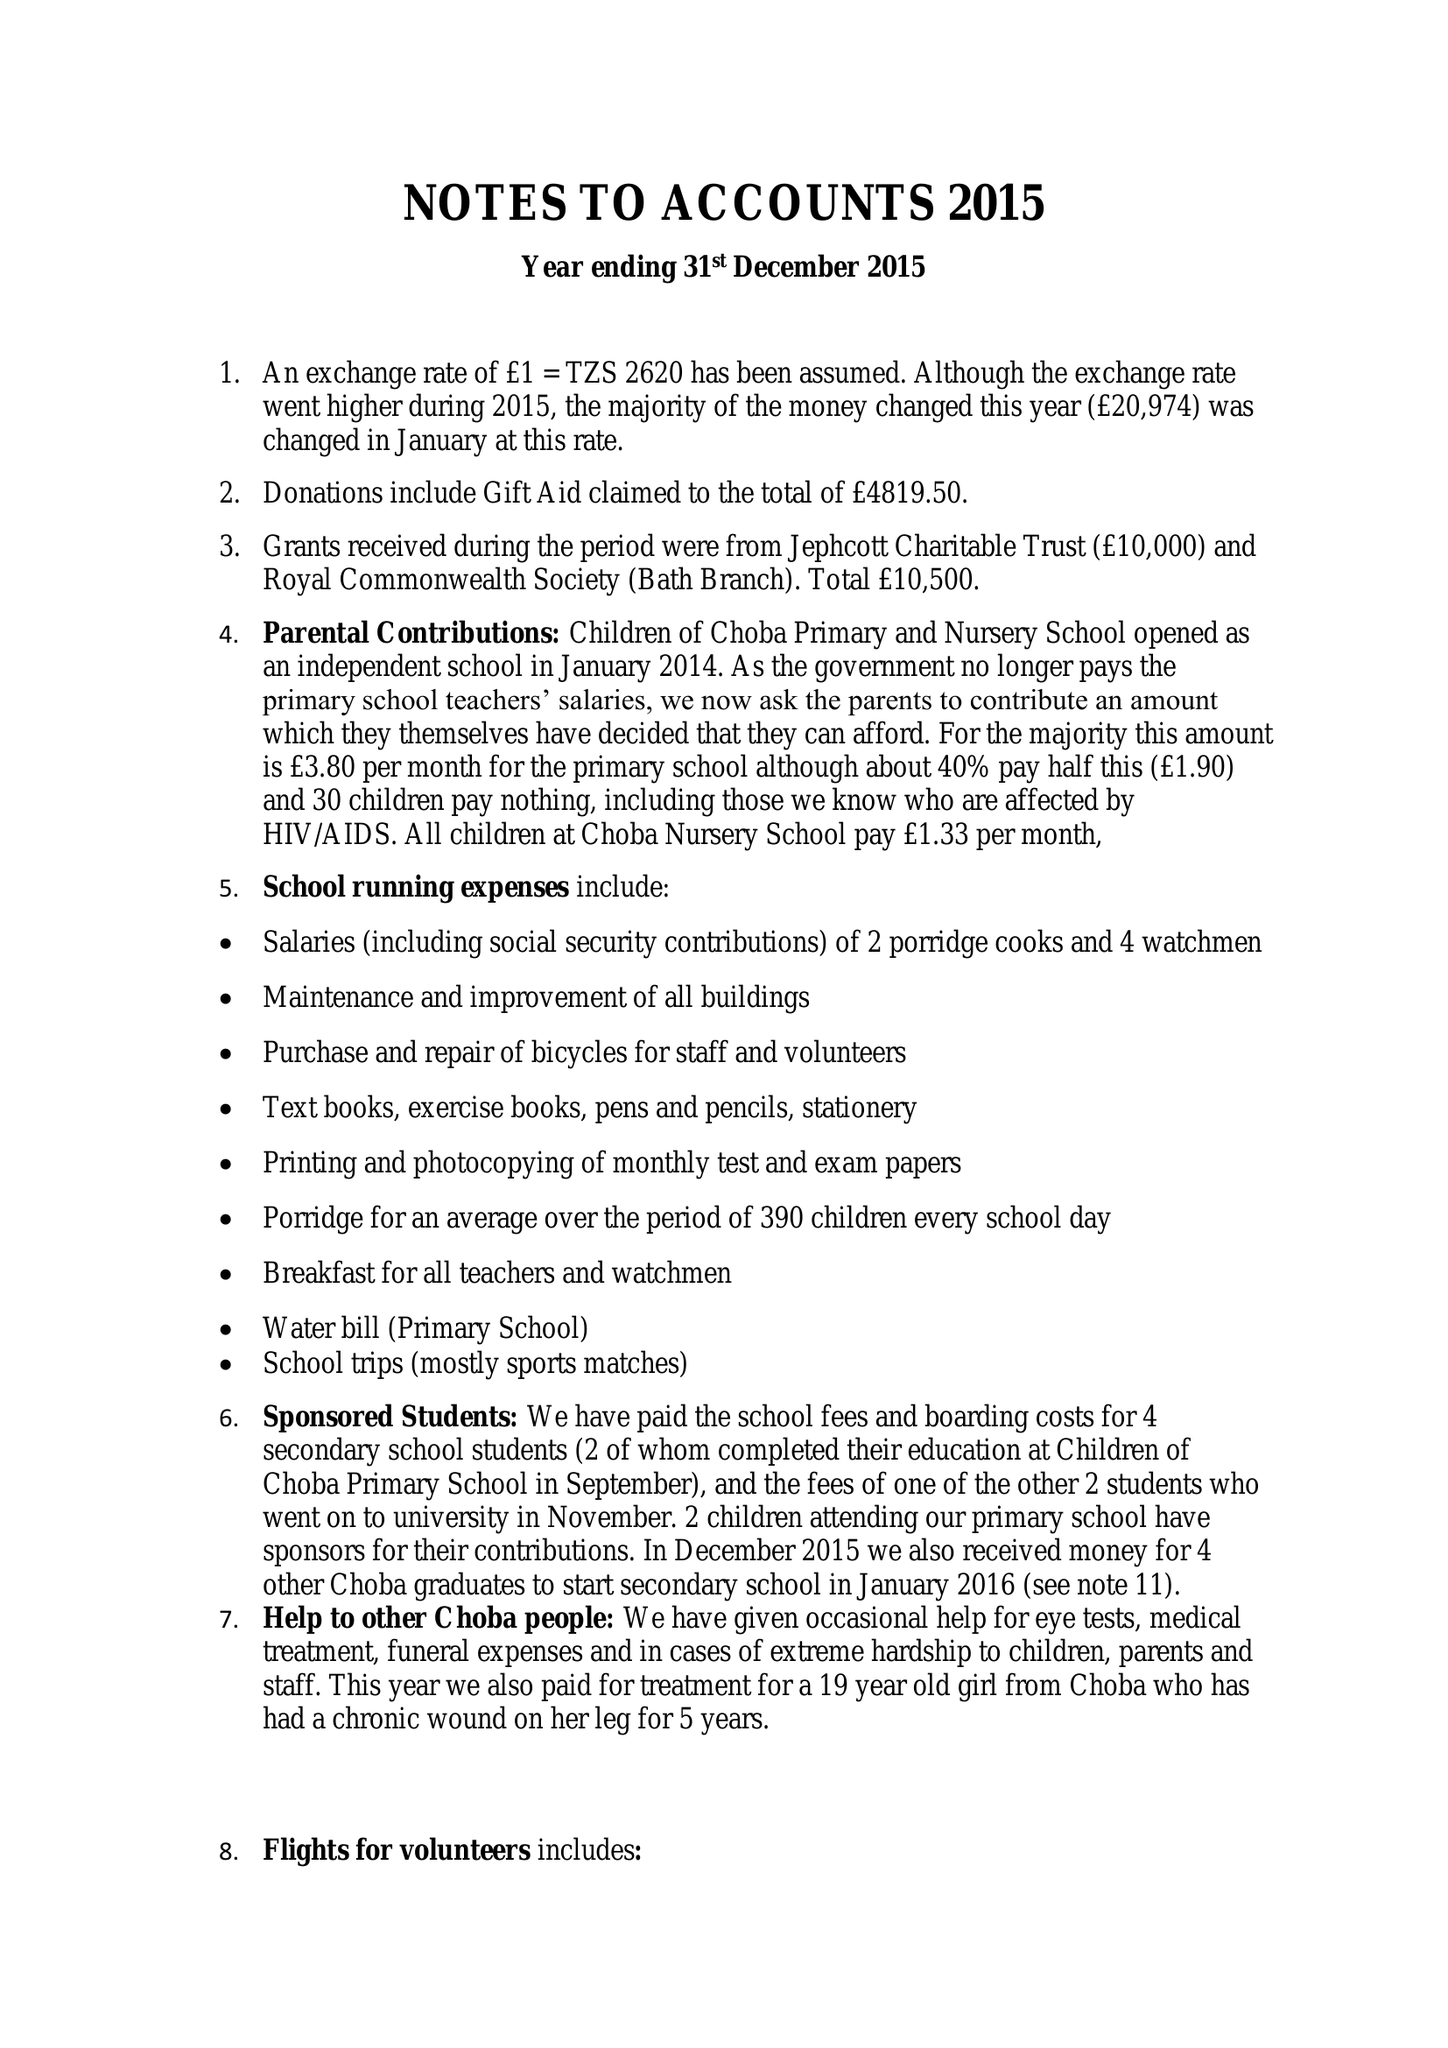What is the value for the address__postcode?
Answer the question using a single word or phrase. BA2 6DE 